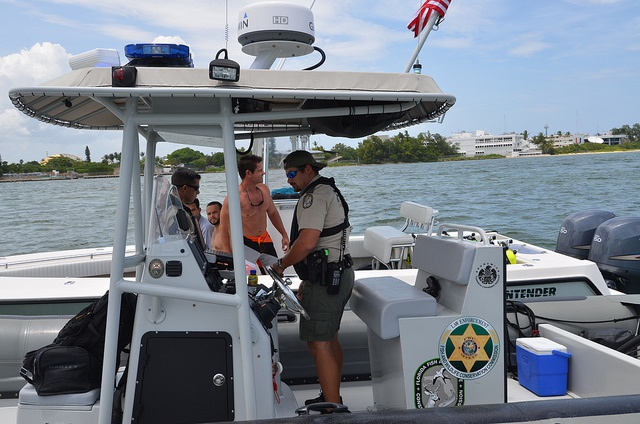Describe the objects in this image and their specific colors. I can see boat in lavender, darkgray, black, gray, and lightgray tones, boat in lavender, lightgray, darkgray, gray, and black tones, people in lavender, black, gray, maroon, and brown tones, people in lavender, maroon, black, brown, and gray tones, and suitcase in lavender, black, gray, and darkgray tones in this image. 